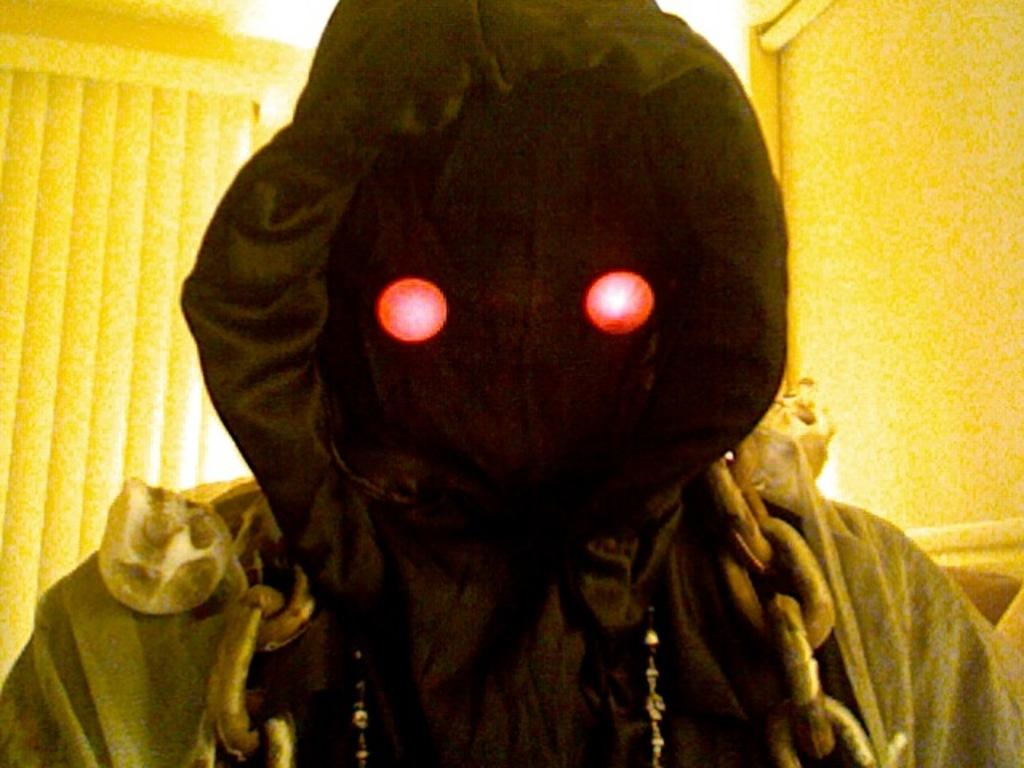Who or what is the main subject in the image? There is a person in the center of the image. What is the person wearing? The person is wearing a costume. What can be seen in the background of the image? There is a wall and lights in the background of the image. How many birds are perched on the person's costume in the image? There are no birds present in the image; the person is wearing a costume, but there are no birds mentioned or visible. 